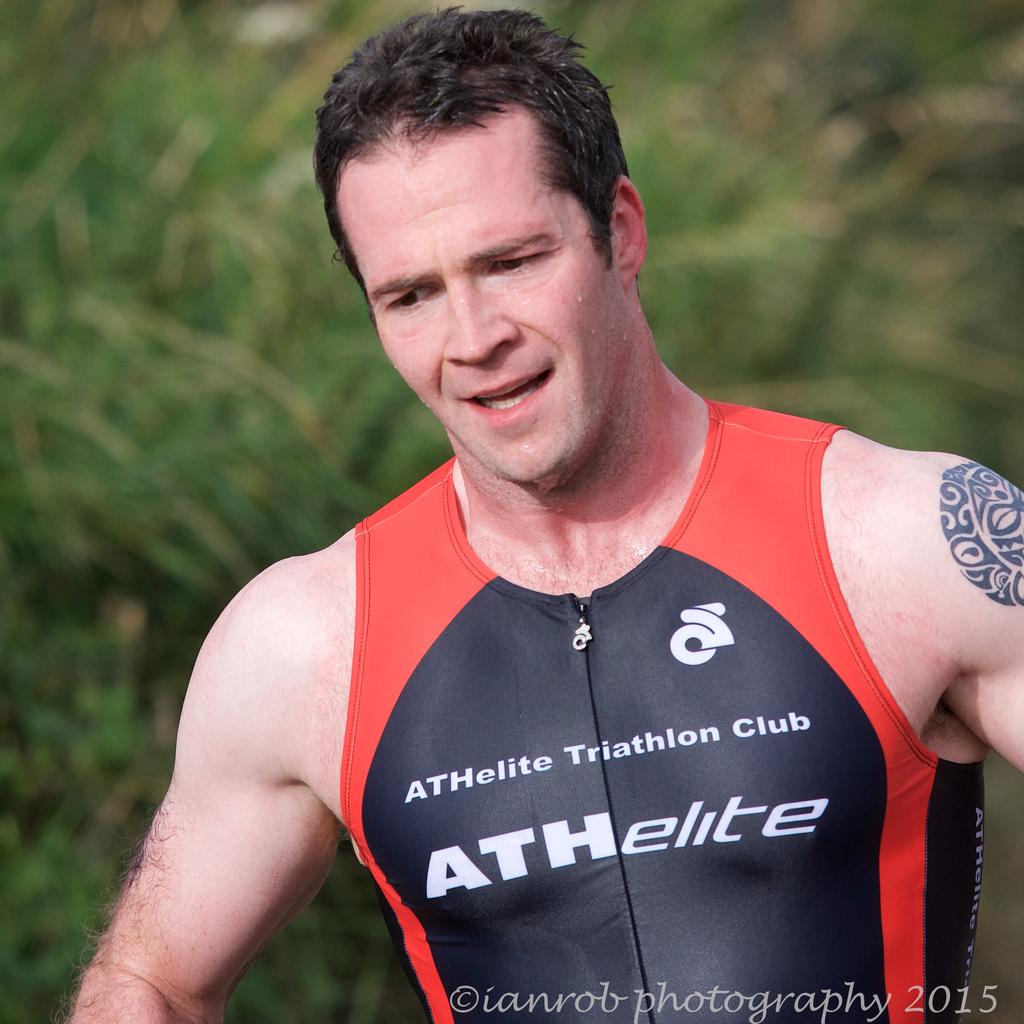<image>
Present a compact description of the photo's key features. A man wearing a sleeveless shirt with ATHelite Triathlon Club on it. 